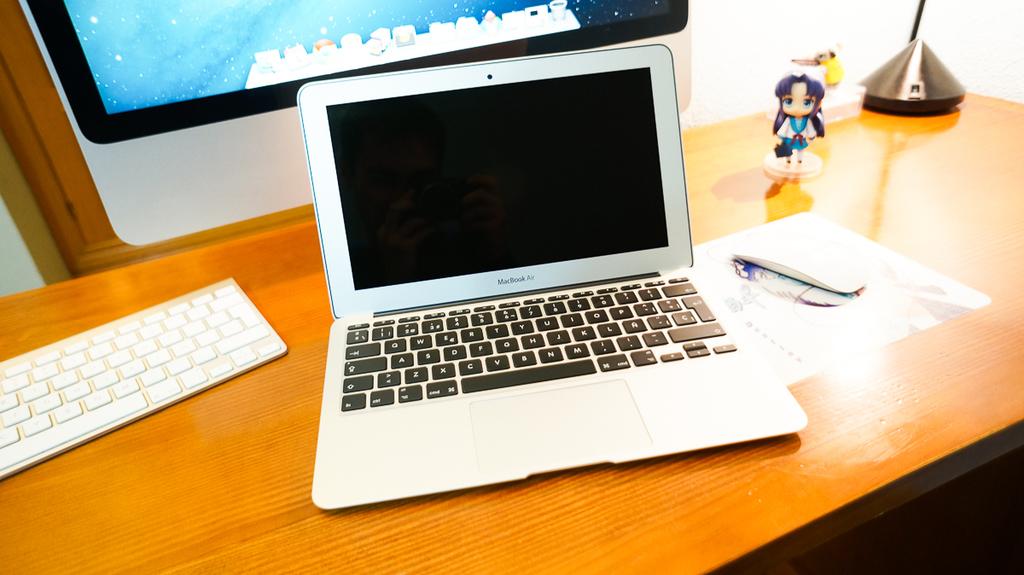What brand of computer is this?
Your response must be concise. Macbook air. What is the first letter in the bottom row?
Keep it short and to the point. Z. 